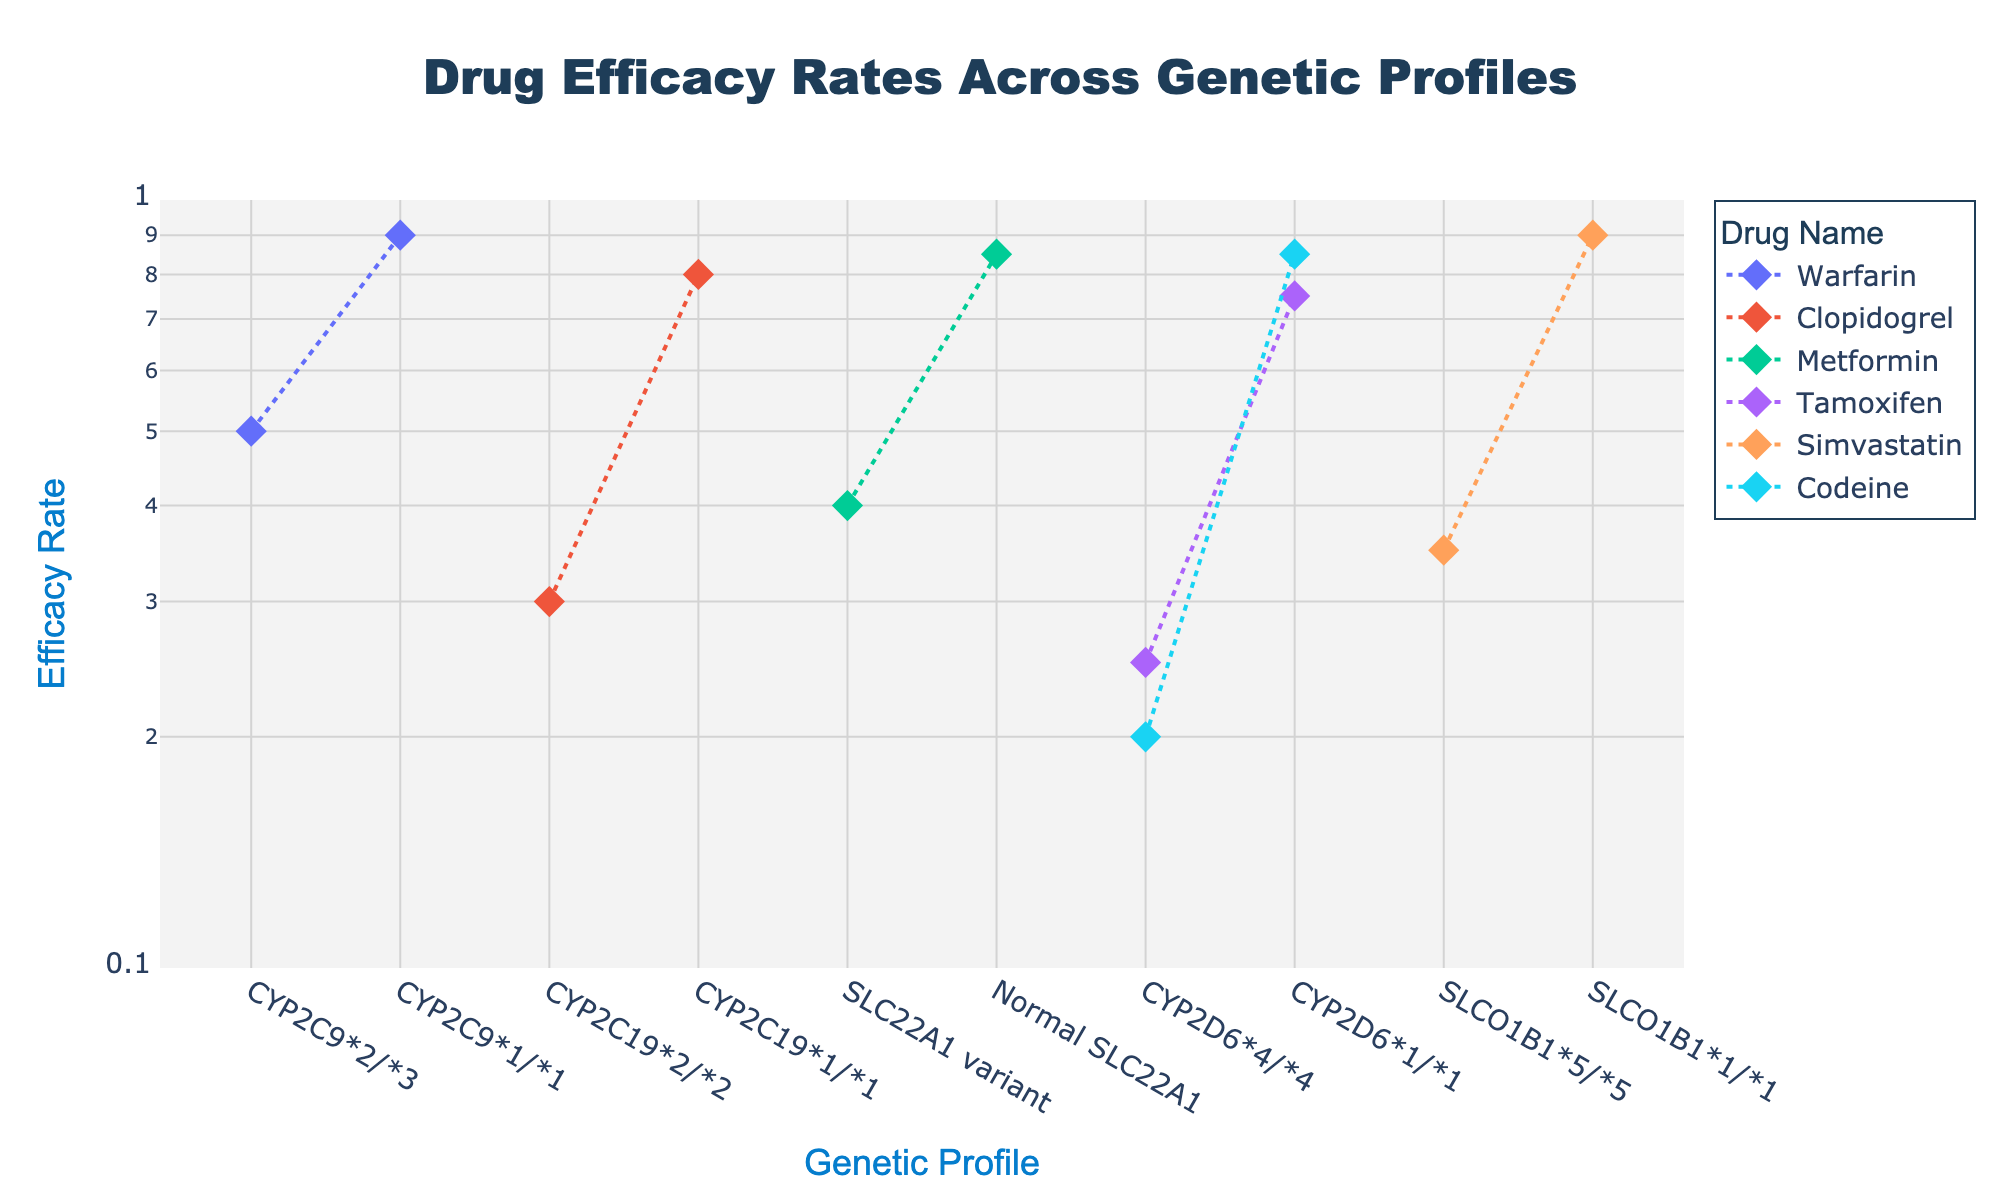How many genetic profiles are shown for the drug Warfarin? There are two data points for Warfarin, each associated with a different genetic profile, one for "CYP2C9*2/*3" and another for "CYP2C9*1/*1".
Answer: 2 What is the efficacy rate of Clopidogrel for the genetic profile CYP2C19*2/*2? By looking at the plot and identifying the point related to Clopidogrel with the genetic profile "CYP2C19*2/*2", the efficacy rate is shown as 0.3.
Answer: 0.3 Which drug has the widest range of efficacy rates across its genetic profiles? To determine this, we compare the highest and lowest efficacy rates for each drug. Warfarin ranges from 0.5 to 0.9, Clopidogrel from 0.3 to 0.8, Metformin from 0.4 to 0.85, Tamoxifen from 0.25 to 0.75, Simvastatin from 0.35 to 0.9, and Codeine from 0.2 to 0.85. Warfarin has the largest range (0.9 - 0.5 = 0.4).
Answer: Warfarin What is the efficacy rate difference between normal SLC22A1 and SLC22A1 variant for Metformin? The efficacy rates for Metformin with "Normal SLC22A1" is 0.85 and with "SLC22A1 variant" is 0.4. The difference is 0.85 - 0.4 = 0.45.
Answer: 0.45 Which drug shows the lowest efficacy rate on the plot? By comparing all the points on the plot, the lowest efficacy rate is 0.2 for Codeine with the genetic profile "CYP2D6*4/*4".
Answer: Codeine For which drug and genetic profile combination is the efficacy rate noted as 0.75? Observing the annotations and traces in the plot, the efficacy rate of 0.75 corresponds to Tamoxifen with the genetic profile 'CYP2D6*1/*1'.
Answer: Tamoxifen What genetic profile has a lower efficacy rate for Simvastatin, "SLCO1B1*5/*5" or "SLCO1B1*1/*1"? On the plot, Simvastatin with "SLCO1B1*5/*5" has an efficacy rate of 0.35 and with "SLCO1B1*1/*1" has an efficacy rate of 0.9. "SLCO1B1*5/*5" has the lower rate.
Answer: "SLCO1B1*5/*5" What is the average efficacy rate for Tamoxifen across its genetic profiles? The efficacy rates for Tamoxifen are 0.25 for "CYP2D6*4/*4" and 0.75 for "CYP2D6*1/*1". The average is calculated as (0.25 + 0.75) / 2 = 0.5.
Answer: 0.5 Which genetic profile-drug pair has the highest efficacy rate on the plot? Reviewing all points, the highest efficacy rate visible is 0.9, which occurs in three pairs: Warfarin (CYP2C9*1/*1), Simvastatin (SLCO1B1*1/*1), and Codeine (CYP2D6*1/*1).
Answer: Warfarin, Simvastatin, Codeine How does the efficacy rate of Codeine for the genetic profile "CYP2D6*1/*1" compare to that of "CYP2D6*4/*4"? For Codeine, the efficacy rate with the "CYP2D6*4/*4" genetic profile is 0.2, whereas with "CYP2D6*1/*1" it is 0.85. "CYP2D6*1/*1" has a higher efficacy rate than "CYP2D6*4/*4".
Answer: Higher 